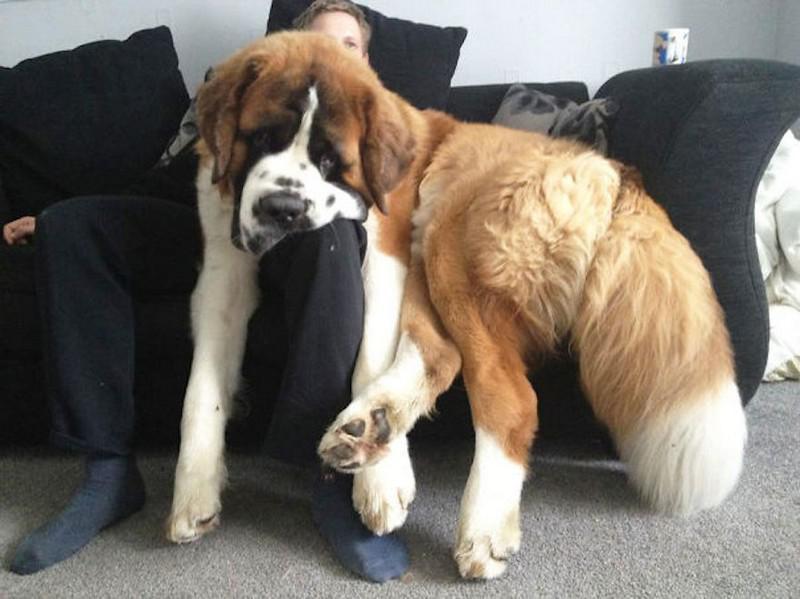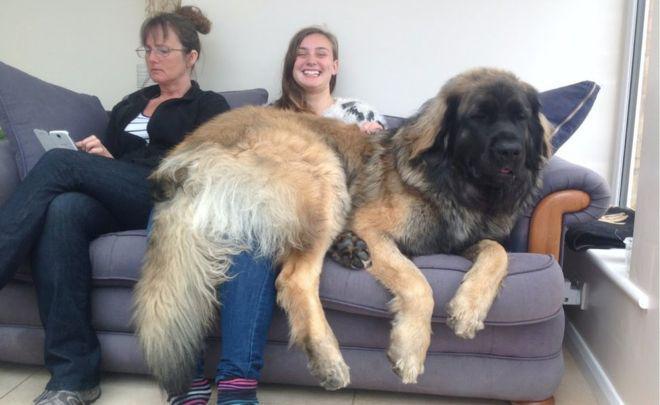The first image is the image on the left, the second image is the image on the right. Analyze the images presented: Is the assertion "Dog sits with humans on a couch." valid? Answer yes or no. Yes. 